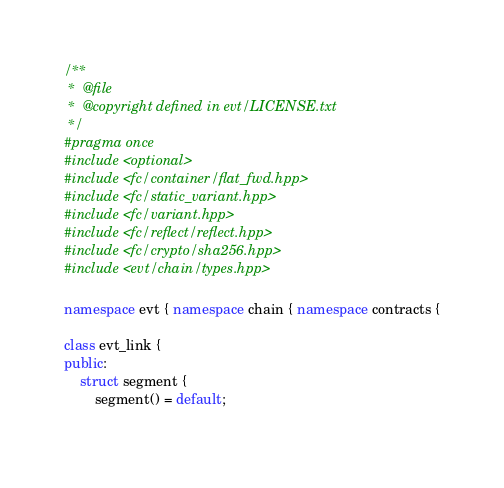Convert code to text. <code><loc_0><loc_0><loc_500><loc_500><_C++_>/**
 *  @file
 *  @copyright defined in evt/LICENSE.txt
 */
#pragma once
#include <optional>
#include <fc/container/flat_fwd.hpp>
#include <fc/static_variant.hpp>
#include <fc/variant.hpp>
#include <fc/reflect/reflect.hpp>
#include <fc/crypto/sha256.hpp>
#include <evt/chain/types.hpp>

namespace evt { namespace chain { namespace contracts {

class evt_link {
public:
    struct segment {
        segment() = default;
        </code> 